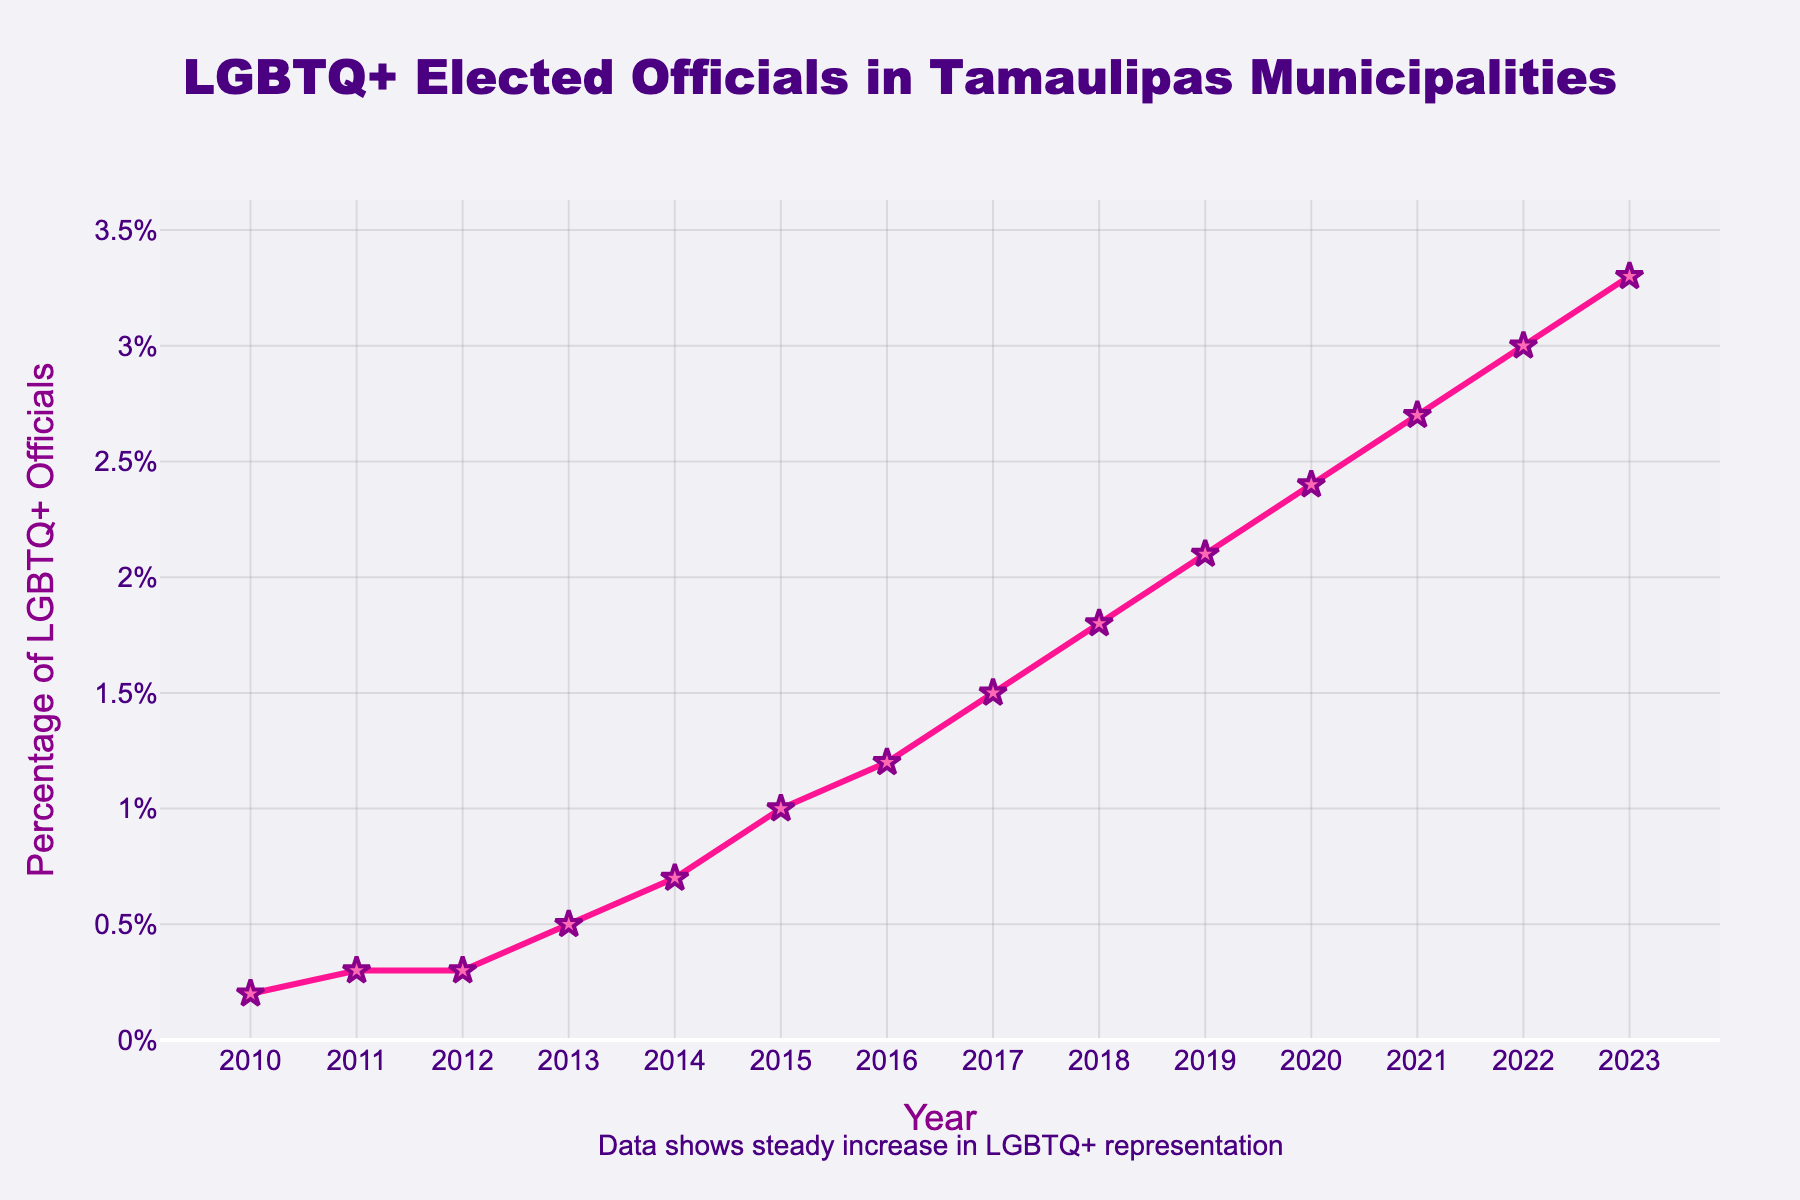what does the trend in percentage of openly LGBTQ+ elected officials in Tamaulipas municipalities over time show? The trend shows a steady increase in the percentage of openly LGBTQ+ elected officials from 2010 to 2023, indicating improving representation over time.
Answer: steady increase What is the percentage difference between 2010 and 2023? First, identify the percentages in 2010 and 2023 from the figure (0.2% and 3.3%, respectively). Subtract the 2010 value from the 2023 value to get the difference: 3.3% - 0.2% = 3.1%.
Answer: 3.1% How much did the percentage of openly LGBTQ+ elected officials increase from 2017 to 2020? Determine the percentages in 2017 and 2020 from the figure (1.5% and 2.4%, respectively). Subtract the 2017 value from the 2020 value to find the increase: 2.4% - 1.5% = 0.9%.
Answer: 0.9% Comparing 2012 and 2017, in which year was the percentage of openly LGBTQ+ elected officials higher, and by how much? Identify the percentages in 2012 and 2017 (0.3% and 1.5%, respectively). Subtract the 2012 value from the 2017 value: 1.5% - 0.3% = 1.2%. Therefore, 2017 was higher.
Answer: 2017, 1.2% Between 2014 and 2018, how did the percentage of LGBTQ+ elected officials change? Identify the percentages in 2014 and 2018 (0.7% and 1.8%, respectively). Compare these values to see that from 0.7% in 2014, it increased to 1.8% in 2018. Calculate the increase: 1.8% - 0.7% = 1.1%.
Answer: increase by 1.1% In what year did the percentage of openly LGBTQ+ elected officials first reach or exceed 1%? Review the values each year on the figure. The percentage first reaches or exceeds 1% in 2015.
Answer: 2015 What is the average annual increase in the percentage of openly LGBTQ+ elected officials from 2010 to 2023? Calculate the total increase over the period (3.3% - 0.2% = 3.1%). Divide the total increase by the number of years (2023 - 2010 = 13 years): 3.1% / 13 ≈ 0.238% per year.
Answer: 0.238% What visual elements in the chart emphasize the trend of increasing representation? The line connecting the data points shows an upward trend consistently over time, and the markers are highlighted in a strong visual color (pink and purple), adding emphasis to each data point.
Answer: upward line, pink and purple markers Between which consecutive years was the smallest increase in percentage observed? Compare the changes year-by-year. The smallest increase is between 2011 and 2012, where the percentage remains constant at 0.3%.
Answer: 2011 and 2012 